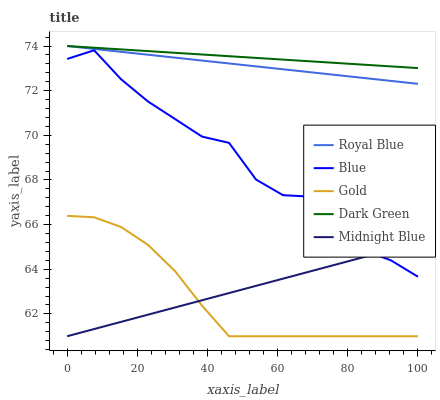Does Royal Blue have the minimum area under the curve?
Answer yes or no. No. Does Royal Blue have the maximum area under the curve?
Answer yes or no. No. Is Royal Blue the smoothest?
Answer yes or no. No. Is Royal Blue the roughest?
Answer yes or no. No. Does Royal Blue have the lowest value?
Answer yes or no. No. Does Midnight Blue have the highest value?
Answer yes or no. No. Is Gold less than Royal Blue?
Answer yes or no. Yes. Is Royal Blue greater than Gold?
Answer yes or no. Yes. Does Gold intersect Royal Blue?
Answer yes or no. No. 